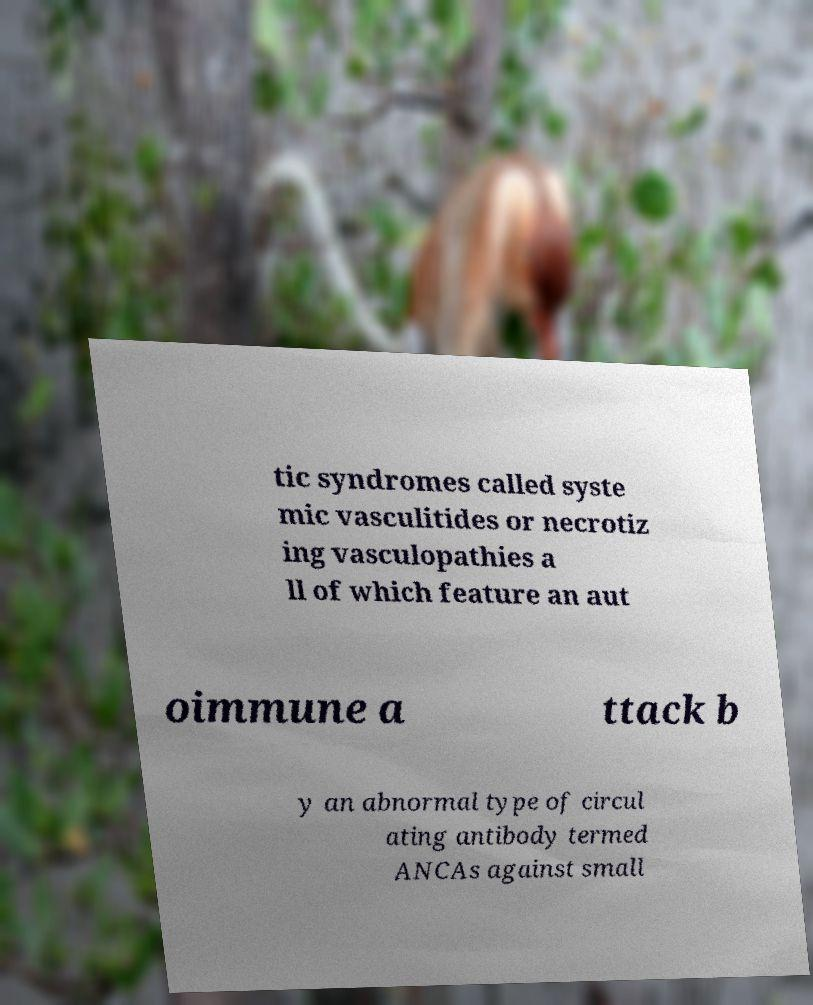Could you extract and type out the text from this image? tic syndromes called syste mic vasculitides or necrotiz ing vasculopathies a ll of which feature an aut oimmune a ttack b y an abnormal type of circul ating antibody termed ANCAs against small 